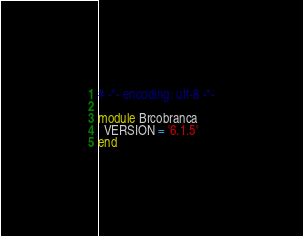Convert code to text. <code><loc_0><loc_0><loc_500><loc_500><_Ruby_># -*- encoding: utf-8 -*-

module Brcobranca
  VERSION = '6.1.5'
end
</code> 